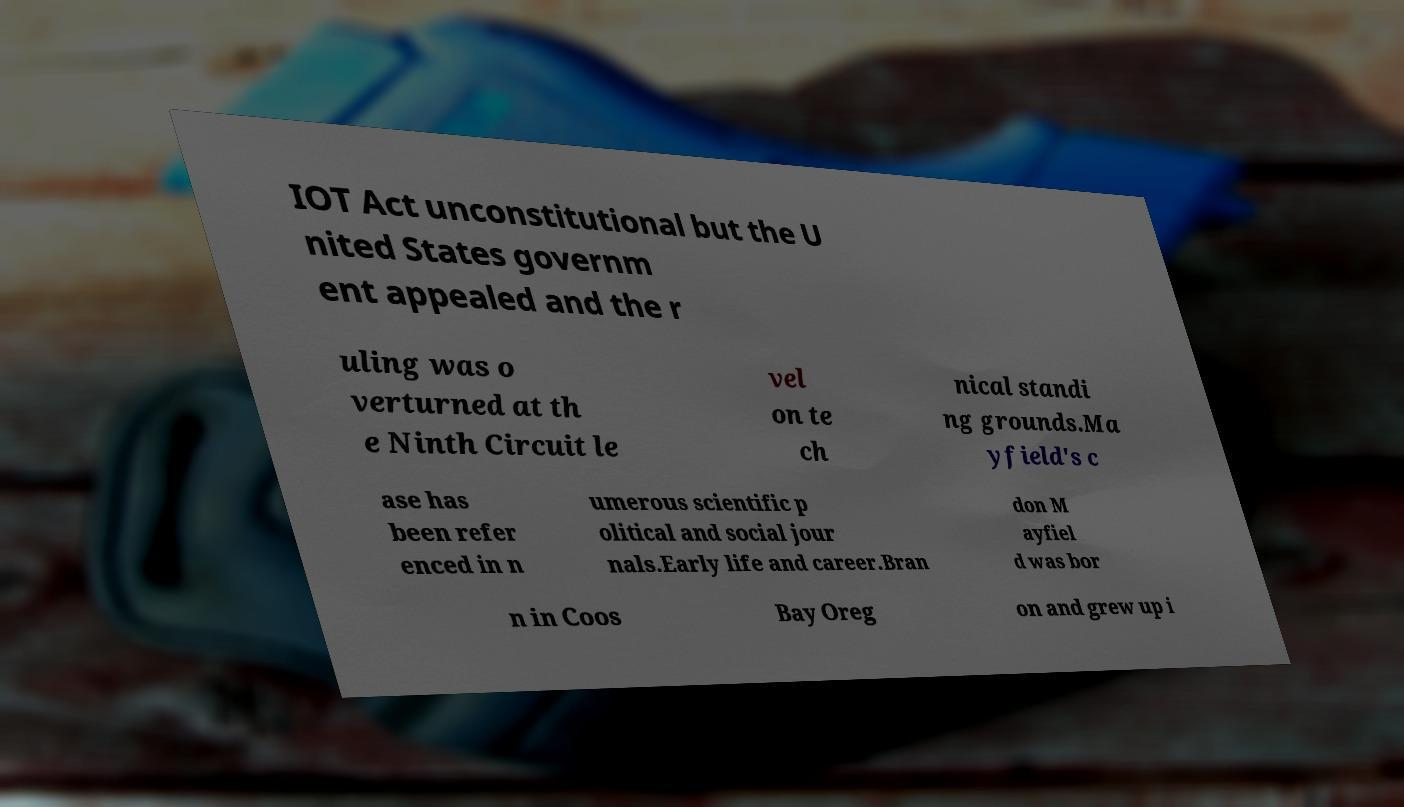Can you accurately transcribe the text from the provided image for me? IOT Act unconstitutional but the U nited States governm ent appealed and the r uling was o verturned at th e Ninth Circuit le vel on te ch nical standi ng grounds.Ma yfield's c ase has been refer enced in n umerous scientific p olitical and social jour nals.Early life and career.Bran don M ayfiel d was bor n in Coos Bay Oreg on and grew up i 